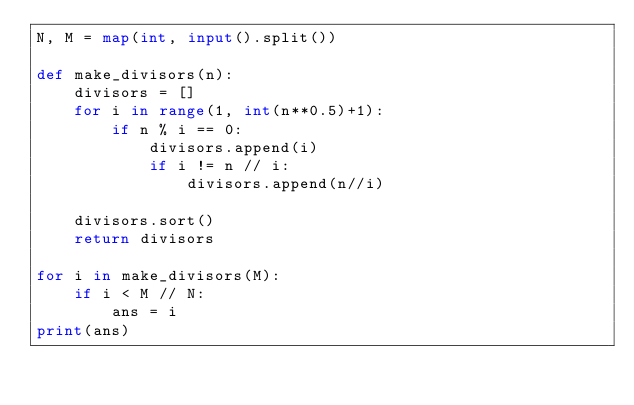Convert code to text. <code><loc_0><loc_0><loc_500><loc_500><_Python_>N, M = map(int, input().split())

def make_divisors(n):
    divisors = []
    for i in range(1, int(n**0.5)+1):
        if n % i == 0:
            divisors.append(i)
            if i != n // i:
                divisors.append(n//i)

    divisors.sort()
    return divisors

for i in make_divisors(M):
    if i < M // N:
        ans = i 
print(ans)</code> 